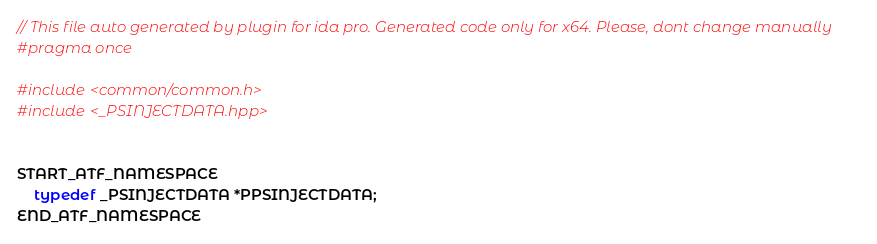Convert code to text. <code><loc_0><loc_0><loc_500><loc_500><_C++_>// This file auto generated by plugin for ida pro. Generated code only for x64. Please, dont change manually
#pragma once

#include <common/common.h>
#include <_PSINJECTDATA.hpp>


START_ATF_NAMESPACE
    typedef _PSINJECTDATA *PPSINJECTDATA;
END_ATF_NAMESPACE
</code> 